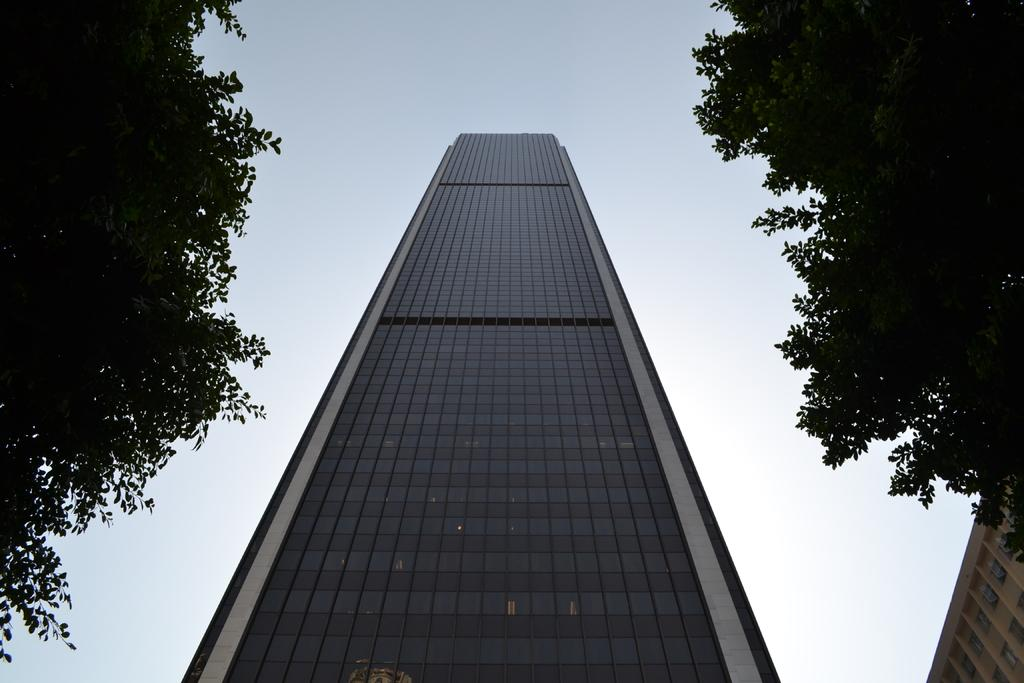What type of structure is present in the image? There is a tall building in the image. Can you identify any natural elements in the image? Yes, there are two trees in the image. What type of art can be seen on the walls of the tall building in the image? There is no mention of any art or paintings on the walls of the tall building in the image. 